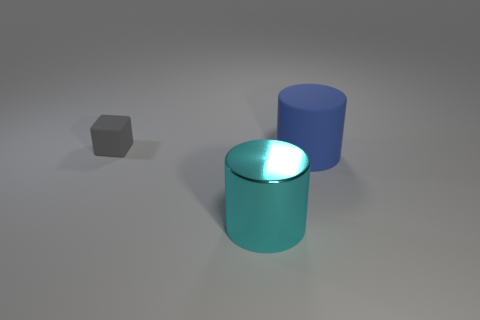What number of things are both behind the large metal cylinder and to the right of the cube?
Provide a succinct answer. 1. There is a large thing that is left of the large cylinder that is on the right side of the object that is in front of the big blue matte object; what is its material?
Your answer should be very brief. Metal. What number of other cubes are made of the same material as the gray cube?
Ensure brevity in your answer.  0. What shape is the rubber thing that is the same size as the shiny thing?
Ensure brevity in your answer.  Cylinder. Are there any rubber cylinders in front of the metallic object?
Make the answer very short. No. Are there any other tiny gray things of the same shape as the gray thing?
Your response must be concise. No. Does the thing behind the big blue cylinder have the same shape as the matte thing that is in front of the gray block?
Keep it short and to the point. No. Is there another gray object that has the same size as the gray thing?
Offer a very short reply. No. Are there the same number of gray things on the right side of the large blue cylinder and metal cylinders on the left side of the metallic cylinder?
Your answer should be compact. Yes. Does the big cylinder that is in front of the big blue thing have the same material as the small cube that is to the left of the cyan object?
Provide a short and direct response. No. 